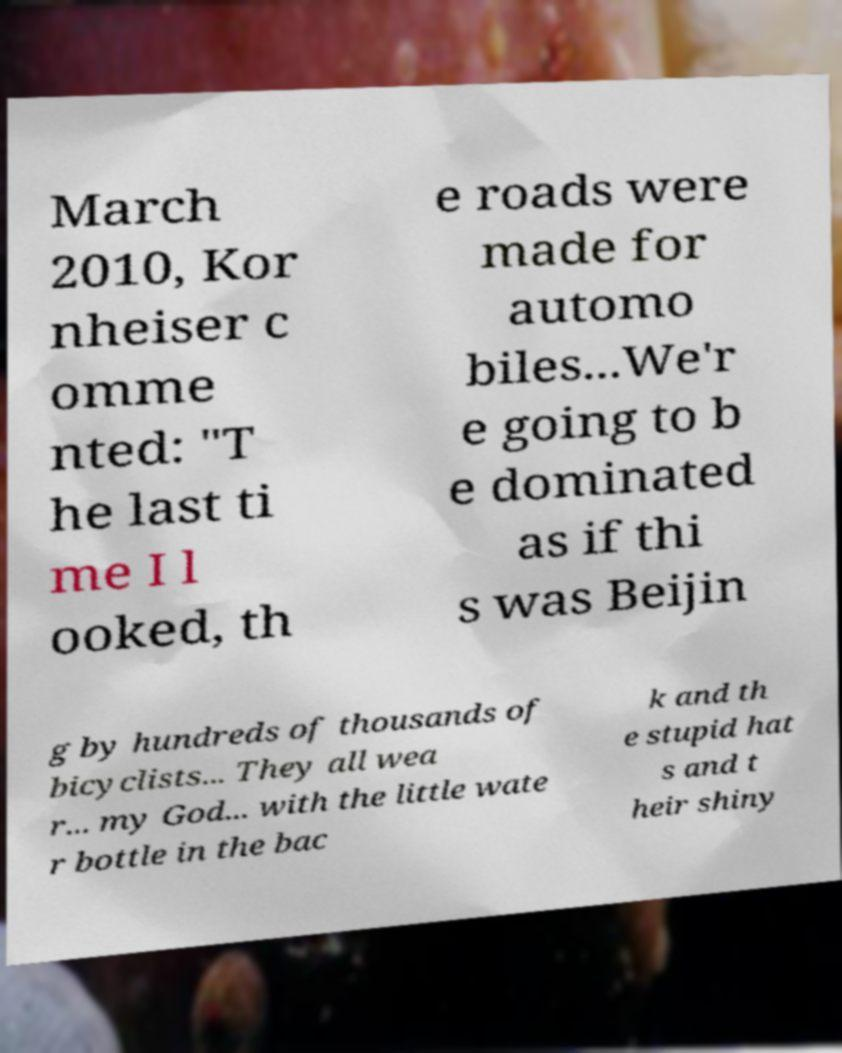Please identify and transcribe the text found in this image. March 2010, Kor nheiser c omme nted: "T he last ti me I l ooked, th e roads were made for automo biles...We'r e going to b e dominated as if thi s was Beijin g by hundreds of thousands of bicyclists... They all wea r... my God... with the little wate r bottle in the bac k and th e stupid hat s and t heir shiny 